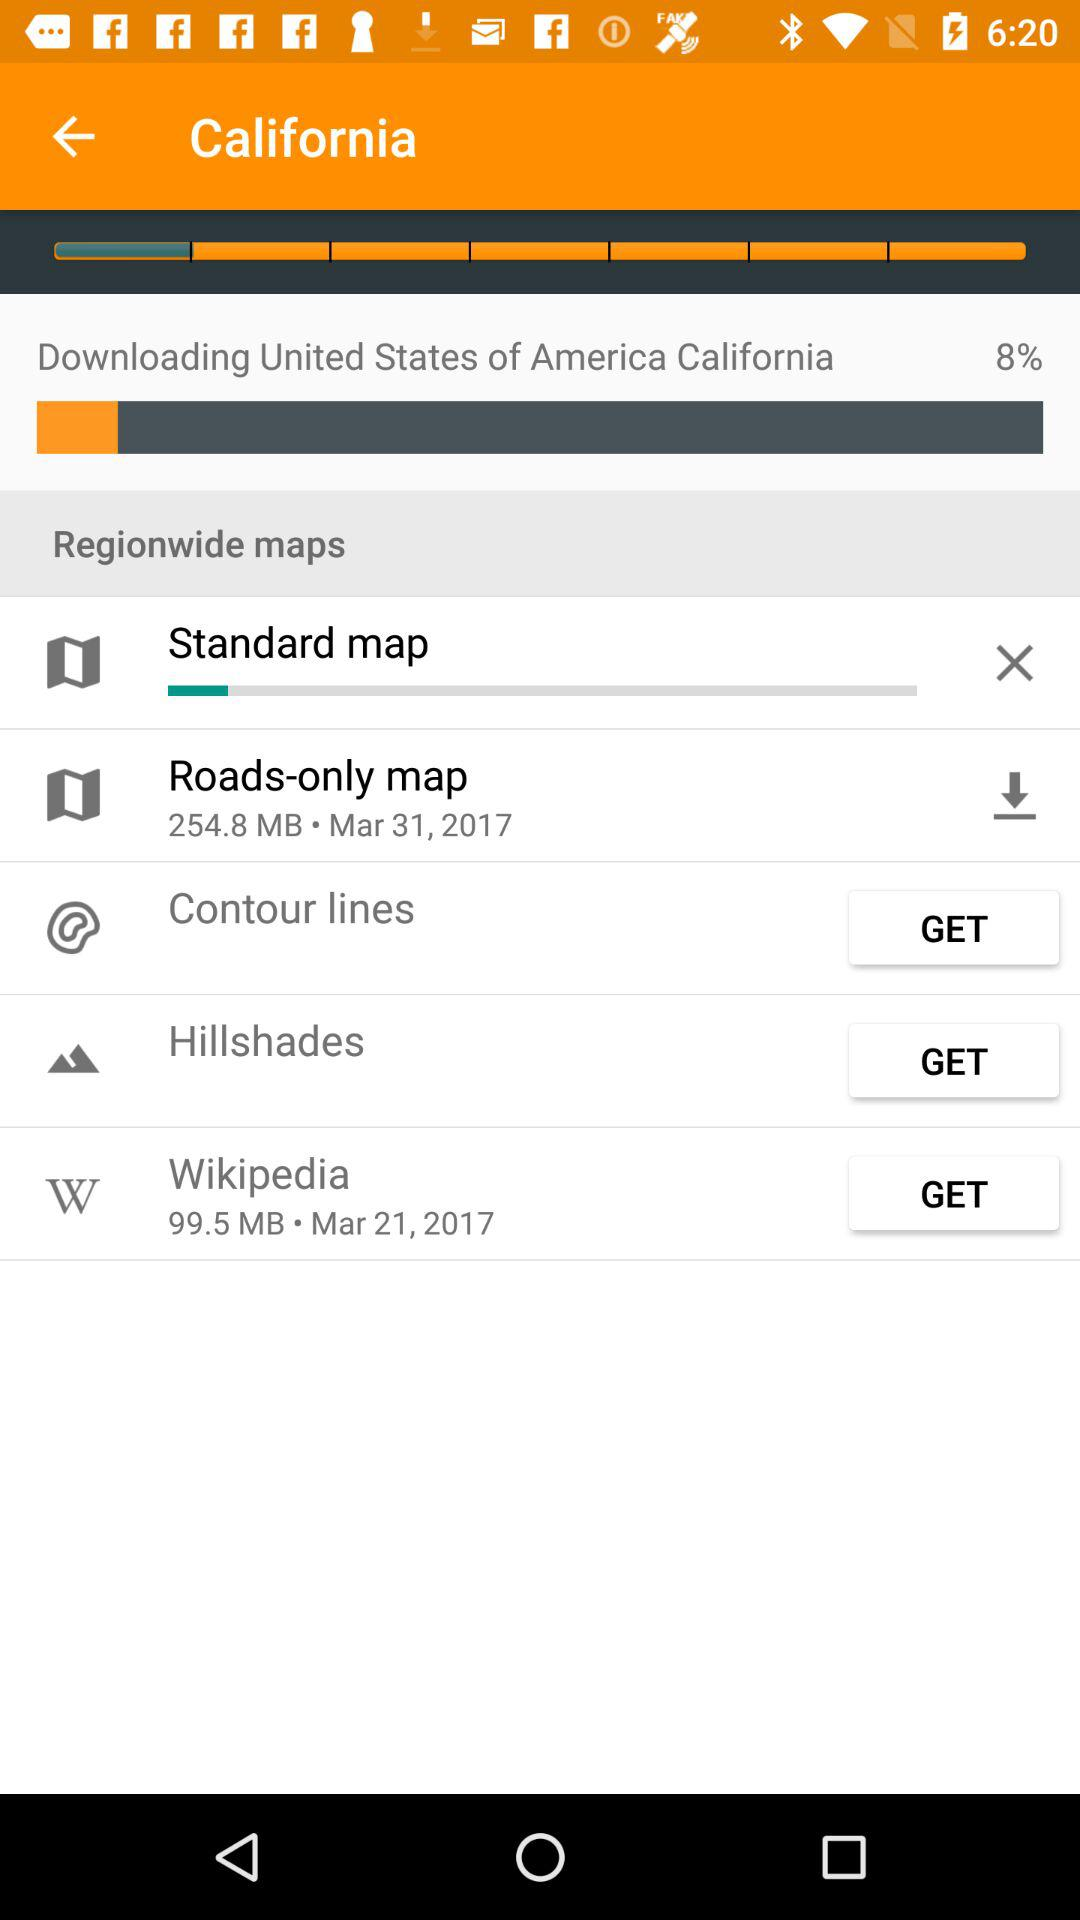How much memory does Wikipedia take to store? It is 99.5 MB. 